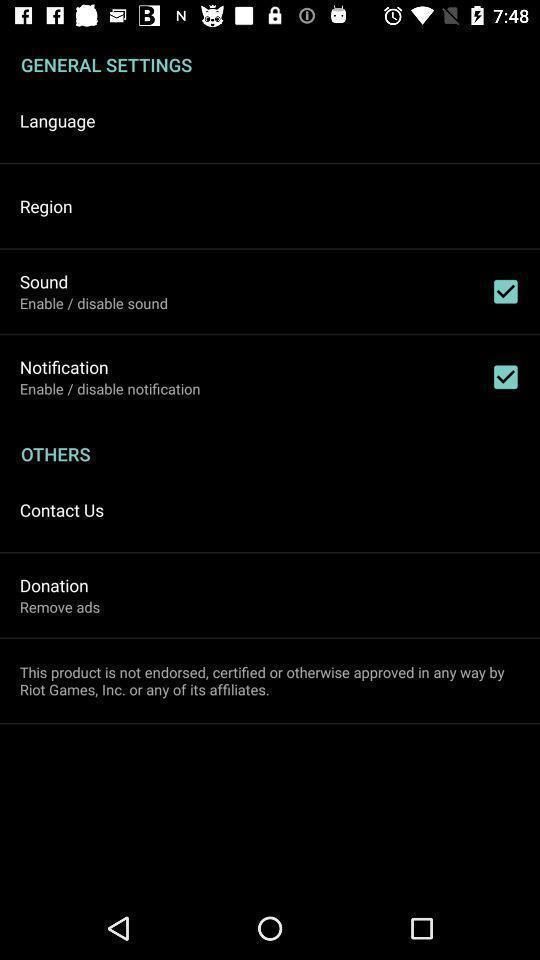Provide a description of this screenshot. Settings page displayed. 